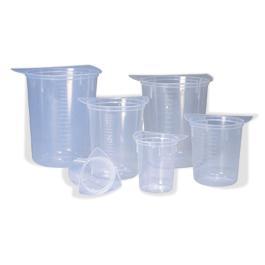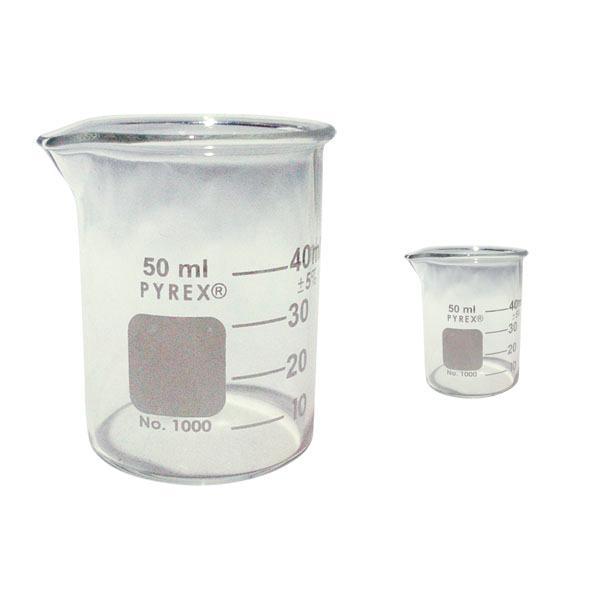The first image is the image on the left, the second image is the image on the right. For the images shown, is this caption "Exactly five beakers in one image and three in the other image are all empty and different sizes." true? Answer yes or no. No. The first image is the image on the left, the second image is the image on the right. For the images shown, is this caption "There are exactly 3 beakers in one of the images." true? Answer yes or no. No. 